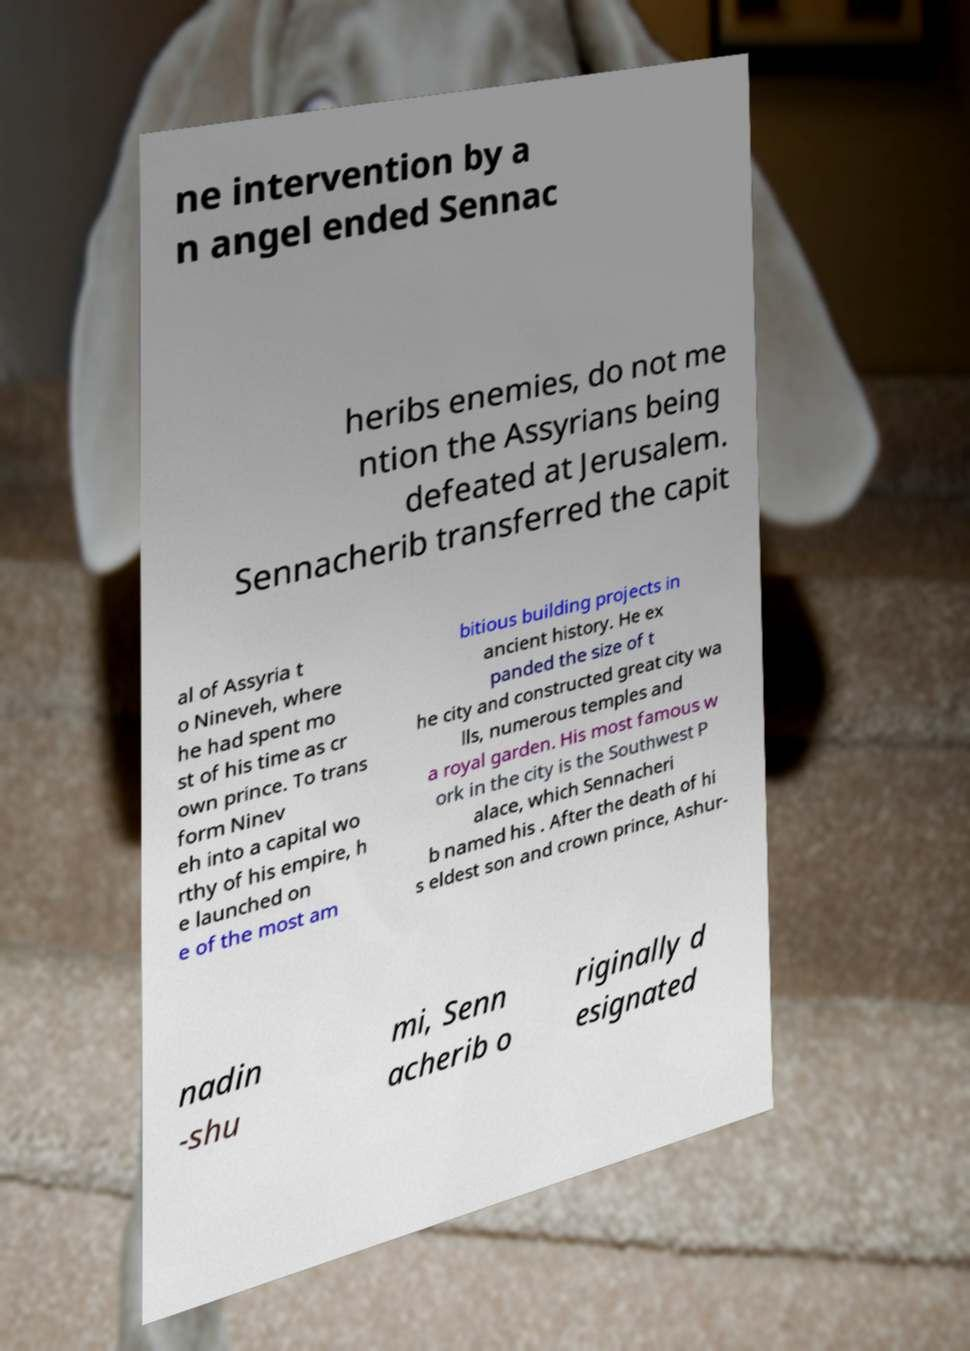Can you accurately transcribe the text from the provided image for me? ne intervention by a n angel ended Sennac heribs enemies, do not me ntion the Assyrians being defeated at Jerusalem. Sennacherib transferred the capit al of Assyria t o Nineveh, where he had spent mo st of his time as cr own prince. To trans form Ninev eh into a capital wo rthy of his empire, h e launched on e of the most am bitious building projects in ancient history. He ex panded the size of t he city and constructed great city wa lls, numerous temples and a royal garden. His most famous w ork in the city is the Southwest P alace, which Sennacheri b named his . After the death of hi s eldest son and crown prince, Ashur- nadin -shu mi, Senn acherib o riginally d esignated 